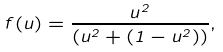<formula> <loc_0><loc_0><loc_500><loc_500>f ( u ) = \frac { u ^ { 2 } } { ( u ^ { 2 } + ( 1 - u ^ { 2 } ) ) } ,</formula> 